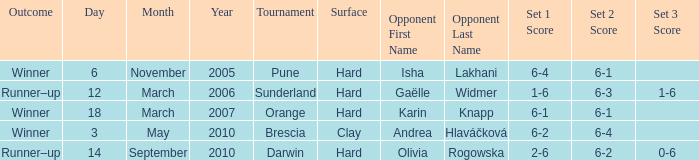What was the result of the contest against isha lakhani? 6-4 6-1. 